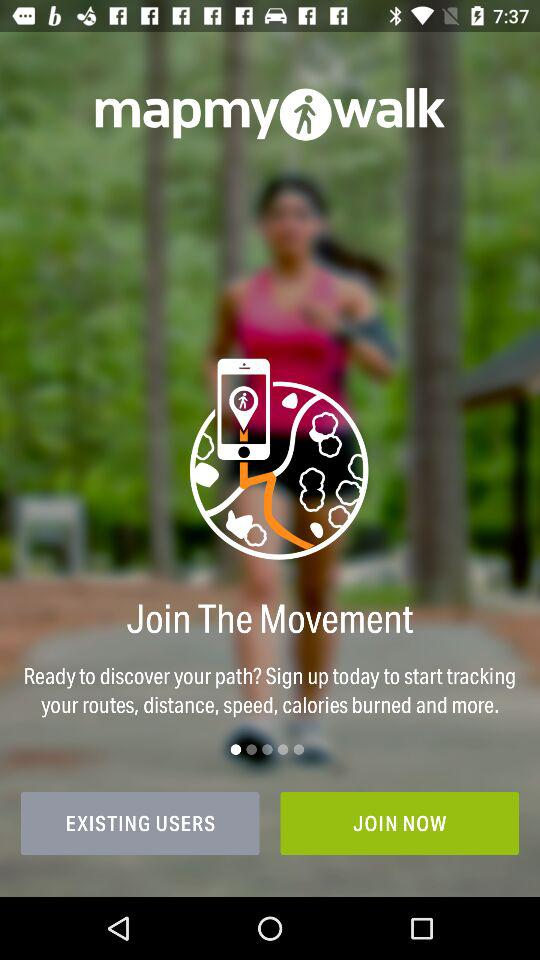What is the name of the application? The name of the application is "mapmywalk". 